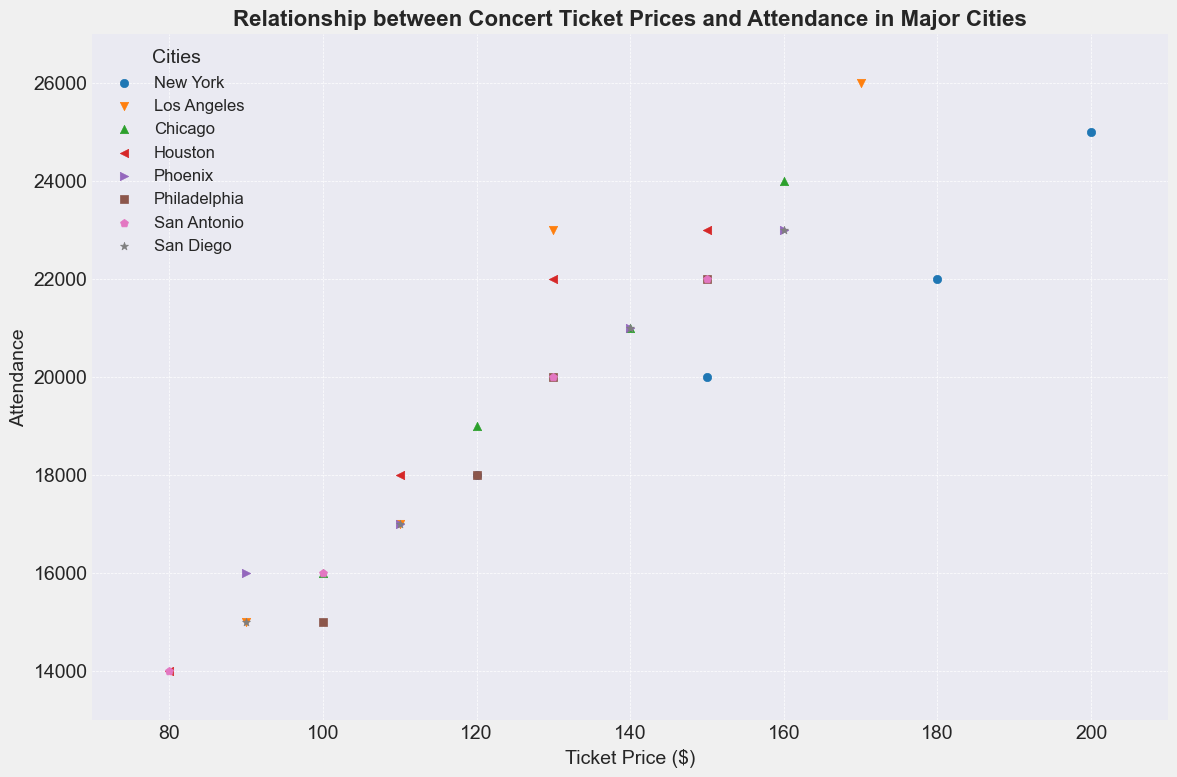What's the overall trend between ticket prices and attendance in the scatter plot? By observing the scatter plot, there's a general trend suggesting that higher ticket prices are associated with higher attendance, especially noticeable in cities like New York and Los Angeles.
Answer: Higher ticket prices generally lead to higher attendance Which city has the highest attendance at the highest ticket price? Looking at the scatter plot, New York City shows the highest attendance at the highest ticket price of $200, with an attendance of 25,000.
Answer: New York City Compare the ticket prices and attendance between New York and Los Angeles when ticket prices are around $170. For New York, at $180, the attendance is 22,000, and for Los Angeles, at $170, the attendance is 26,000.
Answer: Los Angeles has higher attendance Which city has the lowest attendance at the lowest ticket price? Observing the scatter plot, San Antonio shows the lowest attendance at the lowest ticket price of $80, with an attendance of 14,000.
Answer: San Antonio What is the ticket price range that shows the widest spread in attendance for any city? By examining the scatter plot, Los Angeles has a wide spread in attendance ranging from around 15,000 to 26,000 at ticket prices between $90 to $170.
Answer: $90 to $170 for Los Angeles How many cities have an attendance level that reaches or exceeds 20,000 at a ticket price of $150? By observing the scatter plot, New York, Houston, Philadelphia, and San Antonio have attendance levels reaching or exceeding 20,000 at ticket prices of $150.
Answer: Four cities Which city shows the least variation in attendance at different ticket prices? By looking at the plot, Chicago shows relatively less variation in attendance with values clustering between 16,000 and 24,000 across the ticket prices.
Answer: Chicago What is the ticket price for the highest attendance in Chicago, and what is that attendance? The highest attendance in Chicago is at a ticket price of $160 with an attendance of 24,000.
Answer: $160 and 24,000 